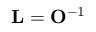Convert formula to latex. <formula><loc_0><loc_0><loc_500><loc_500>{ L } = { O } ^ { - 1 }</formula> 